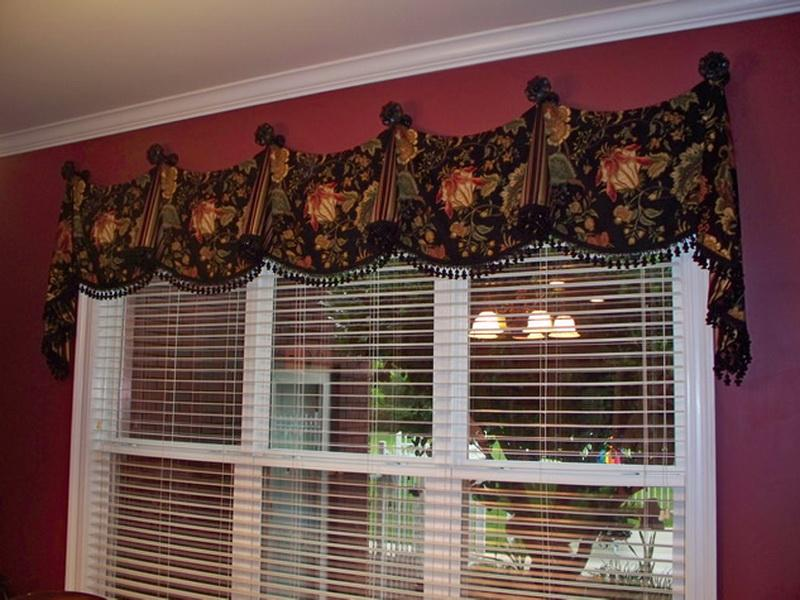Considering the design and style of the window treatment, what might be the overall aesthetic or theme of the room's decor, and how does the window treatment contribute to that aesthetic? Observing the window treatment, we can infer that the room exudes a traditional aesthetic with perhaps a Regency or Victorian inspiration. The substantial floral valance, adorned with sweeping tassels and mounted on ornamental rosettes, implies a love for classic elegance and detail. The deep, regal colors of the window treatment add a layer of sophistication and work harmoniously with the vivid wall paint to suggest an environment that values historical beauty and comfort. Such a window dressing not only commands attention but also sets the tone for complementary furnishings, likely vintage or antique, to create a cohesive, grand ambience throughout the room. 